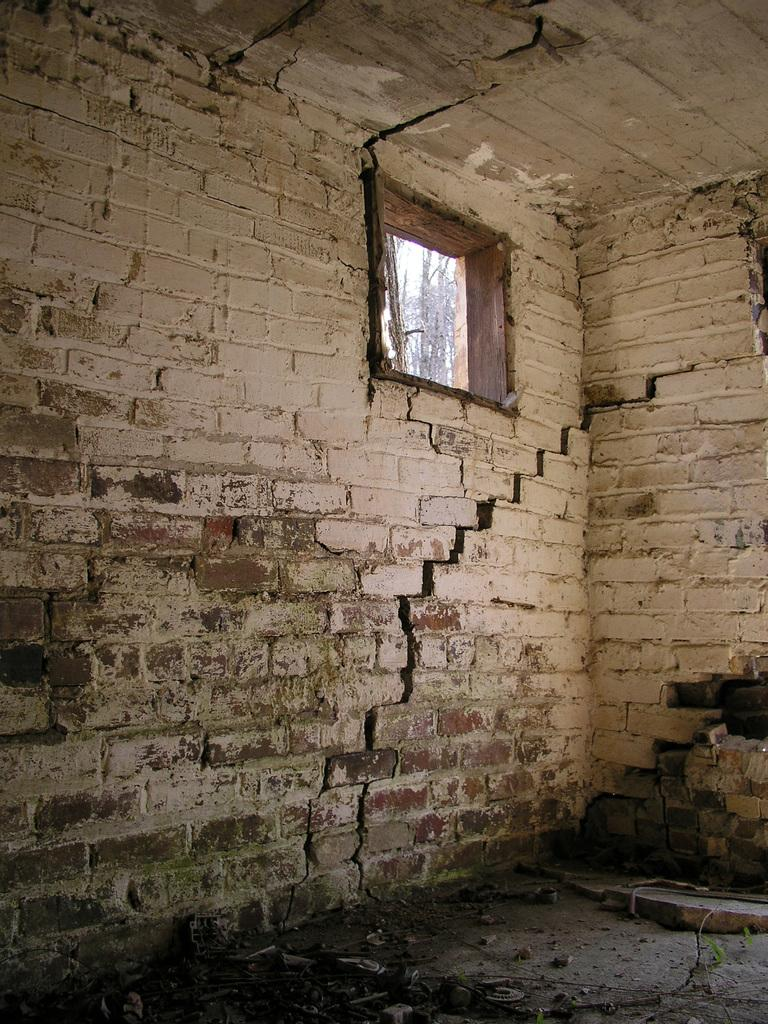What type of view is shown in the image? The image is an inside view. What can be seen on one of the walls in the image? There is a window on a wall in the image. What is the surface beneath the window? There are stones on the ground in the image. What type of crime is being committed in the image? There is no crime being committed in the image; it shows an inside view with a window and stones on the ground. How is the chain used in the image? There is no chain present in the image. 